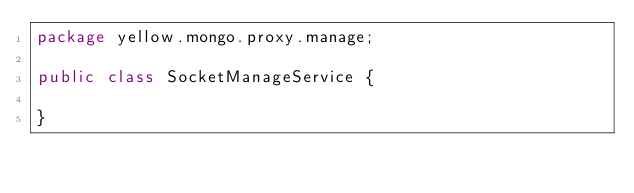<code> <loc_0><loc_0><loc_500><loc_500><_Java_>package yellow.mongo.proxy.manage;

public class SocketManageService {

}
</code> 